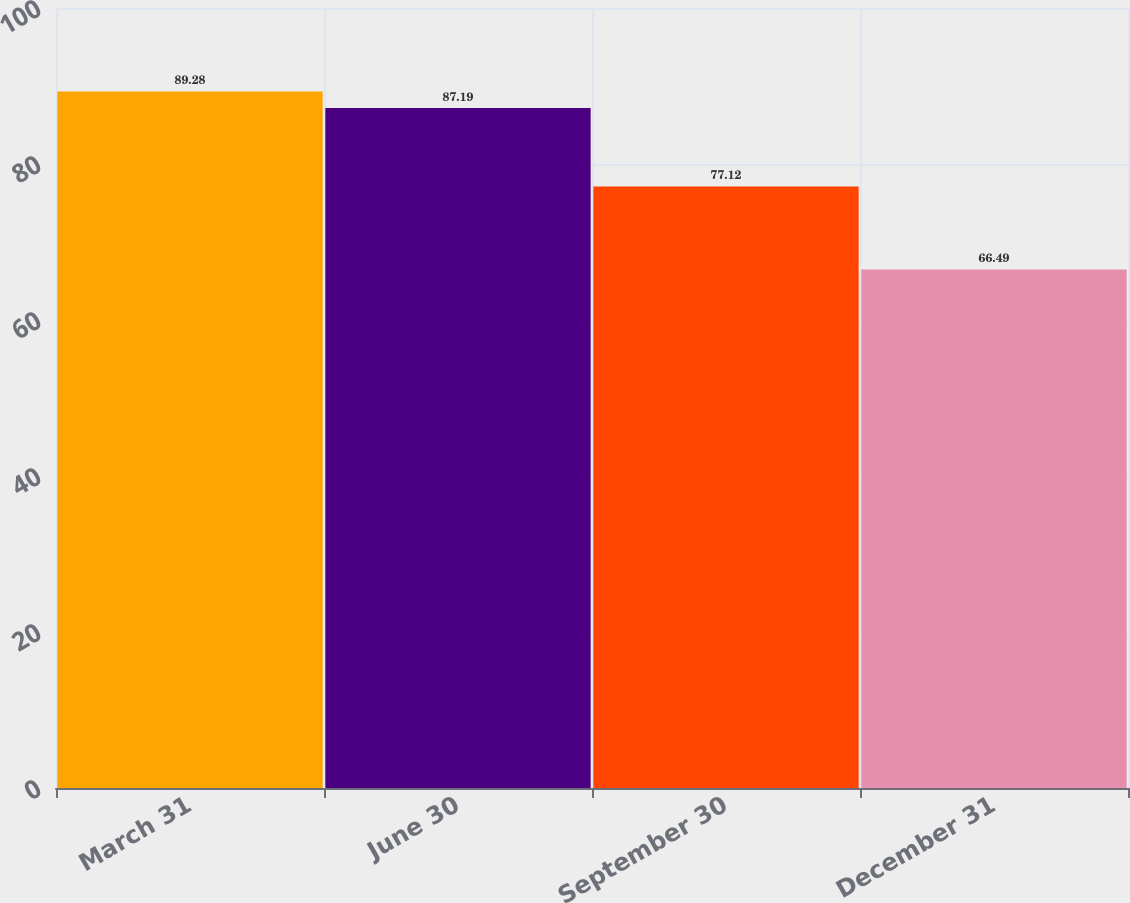Convert chart to OTSL. <chart><loc_0><loc_0><loc_500><loc_500><bar_chart><fcel>March 31<fcel>June 30<fcel>September 30<fcel>December 31<nl><fcel>89.28<fcel>87.19<fcel>77.12<fcel>66.49<nl></chart> 